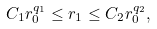<formula> <loc_0><loc_0><loc_500><loc_500>C _ { 1 } r _ { 0 } ^ { q _ { 1 } } \leq r _ { 1 } \leq C _ { 2 } r _ { 0 } ^ { q _ { 2 } } ,</formula> 